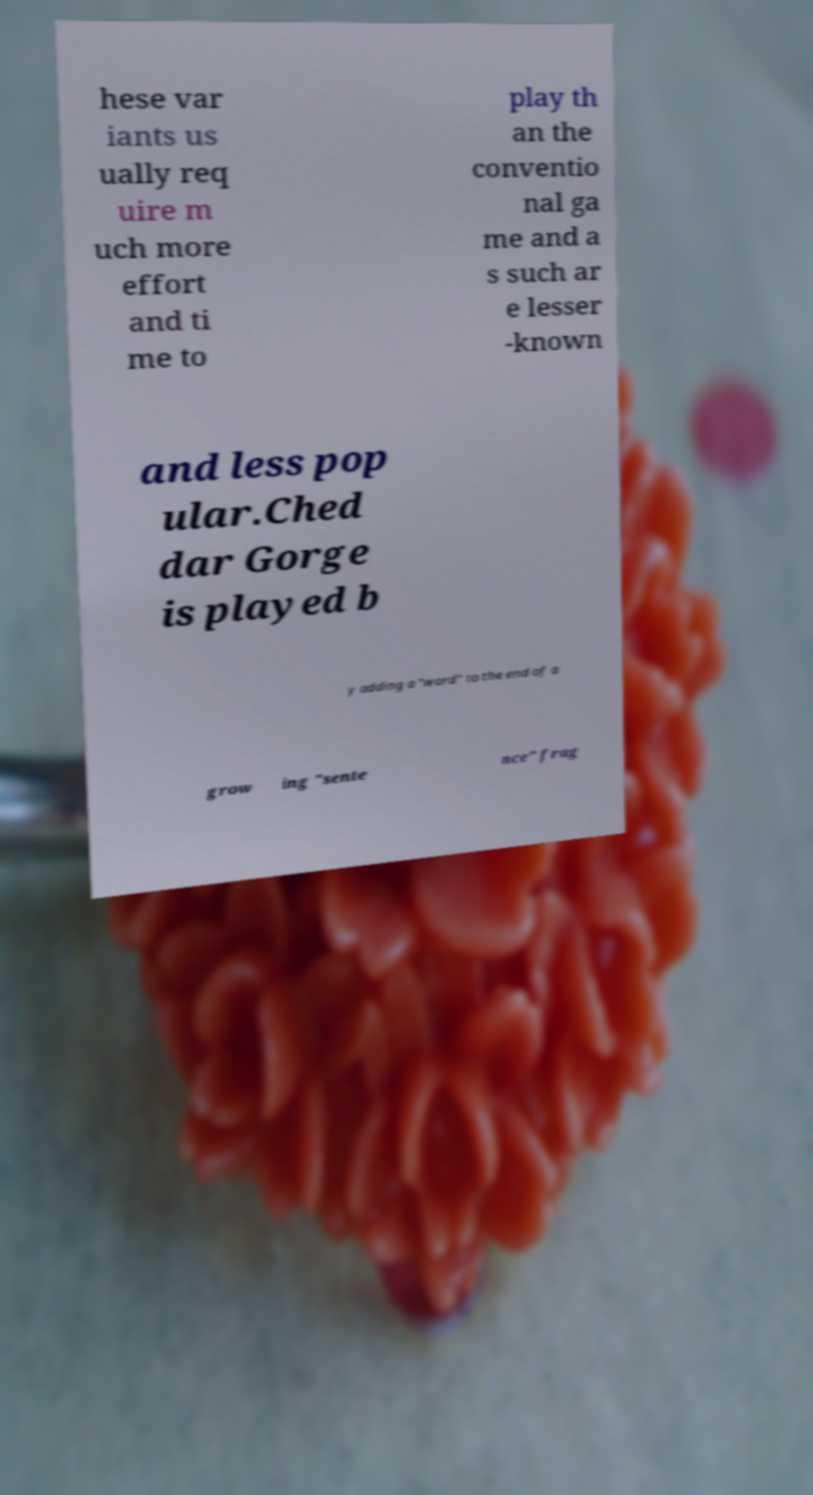I need the written content from this picture converted into text. Can you do that? hese var iants us ually req uire m uch more effort and ti me to play th an the conventio nal ga me and a s such ar e lesser -known and less pop ular.Ched dar Gorge is played b y adding a "word" to the end of a grow ing "sente nce" frag 